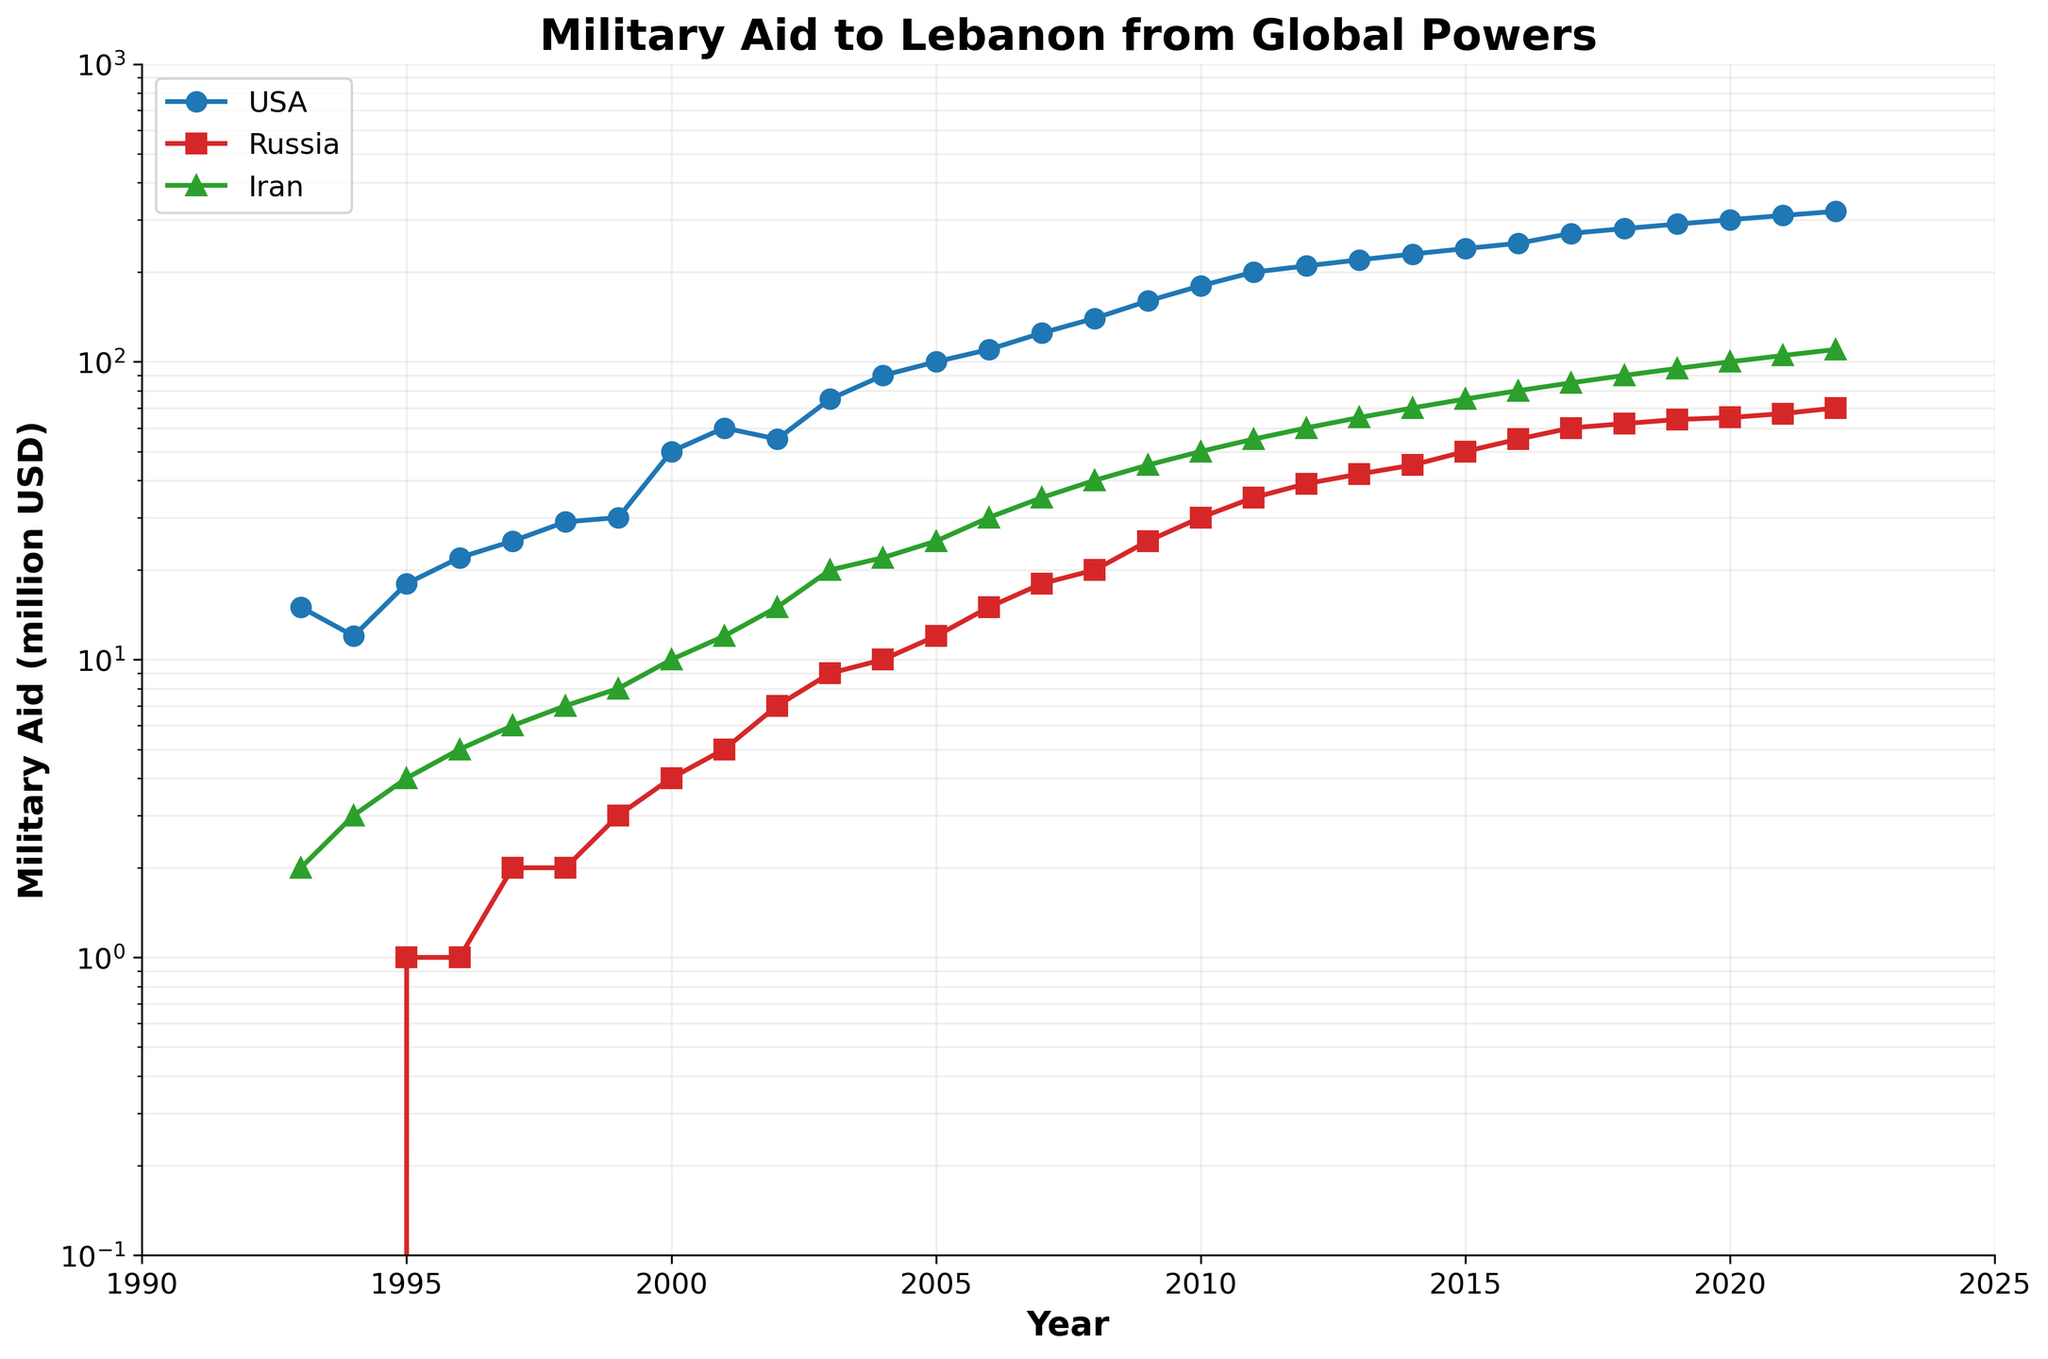What is the title of the plot? The title is located at the top of the plot in bold font.
Answer: Military Aid to Lebanon from Global Powers Which countries' military aid is shown in the plot? The country names are indicated by the three different lines in the plot with respective labels in the legend on the upper left.
Answer: USA, Russia, Iran What was the military aid provided by the USA in 2005? Locate the data point for the USA line corresponding to the year 2005 on the x-axis, then check the value on the y-axis.
Answer: 100 million USD How did Iran's military aid to Lebanon change from 1993 to 2022? Identify the points for Iran at 1993 and 2022, and describe the trend by observing the line's slope.
Answer: It increased from 2 million USD to 110 million USD In which year did Russia's military aid first reach 20 million USD? Find the intersection point of Russia's military aid line with the 20 million USD mark on the y-axis and trace it back to the x-axis (year).
Answer: 2008 Which country provided the most military aid to Lebanon in 2010? Compare the data points for each country at the year 2010 to see which is highest.
Answer: USA Compare the growth rate of military aid from the USA and Iran from 2000 to 2010. Observe the slope of the respective lines for USA and Iran between 2000 and 2010. USA has a steeper slope indicating a higher growth rate compared to Iran.
Answer: The USA had a higher growth rate What is the overall trend in military aid from Russia? Observe the shape and direction of the Russia line across the entire x-axis (years). The line shows a gradual increase.
Answer: Gradual increase Between 1995 and 2005, how did the military aid from Russia and Iran compare in terms of fluctuations? Compare the lines for Russia and Iran between these years. Russia's aid shows a few steps increase while Iran's aid shows a more steady and gradual increase.
Answer: Russia's aid fluctuated more than Iran's aid What can be said about the military aid dynamics from these global powers over the period shown in the plot? A comparative observation of all three lines shows that USA consistently provided the most significant aid, followed by Iran, while Russia had the least contribution with gradual increments.
Answer: USA provided the most aid, followed by Iran, with Russia contributing the least 